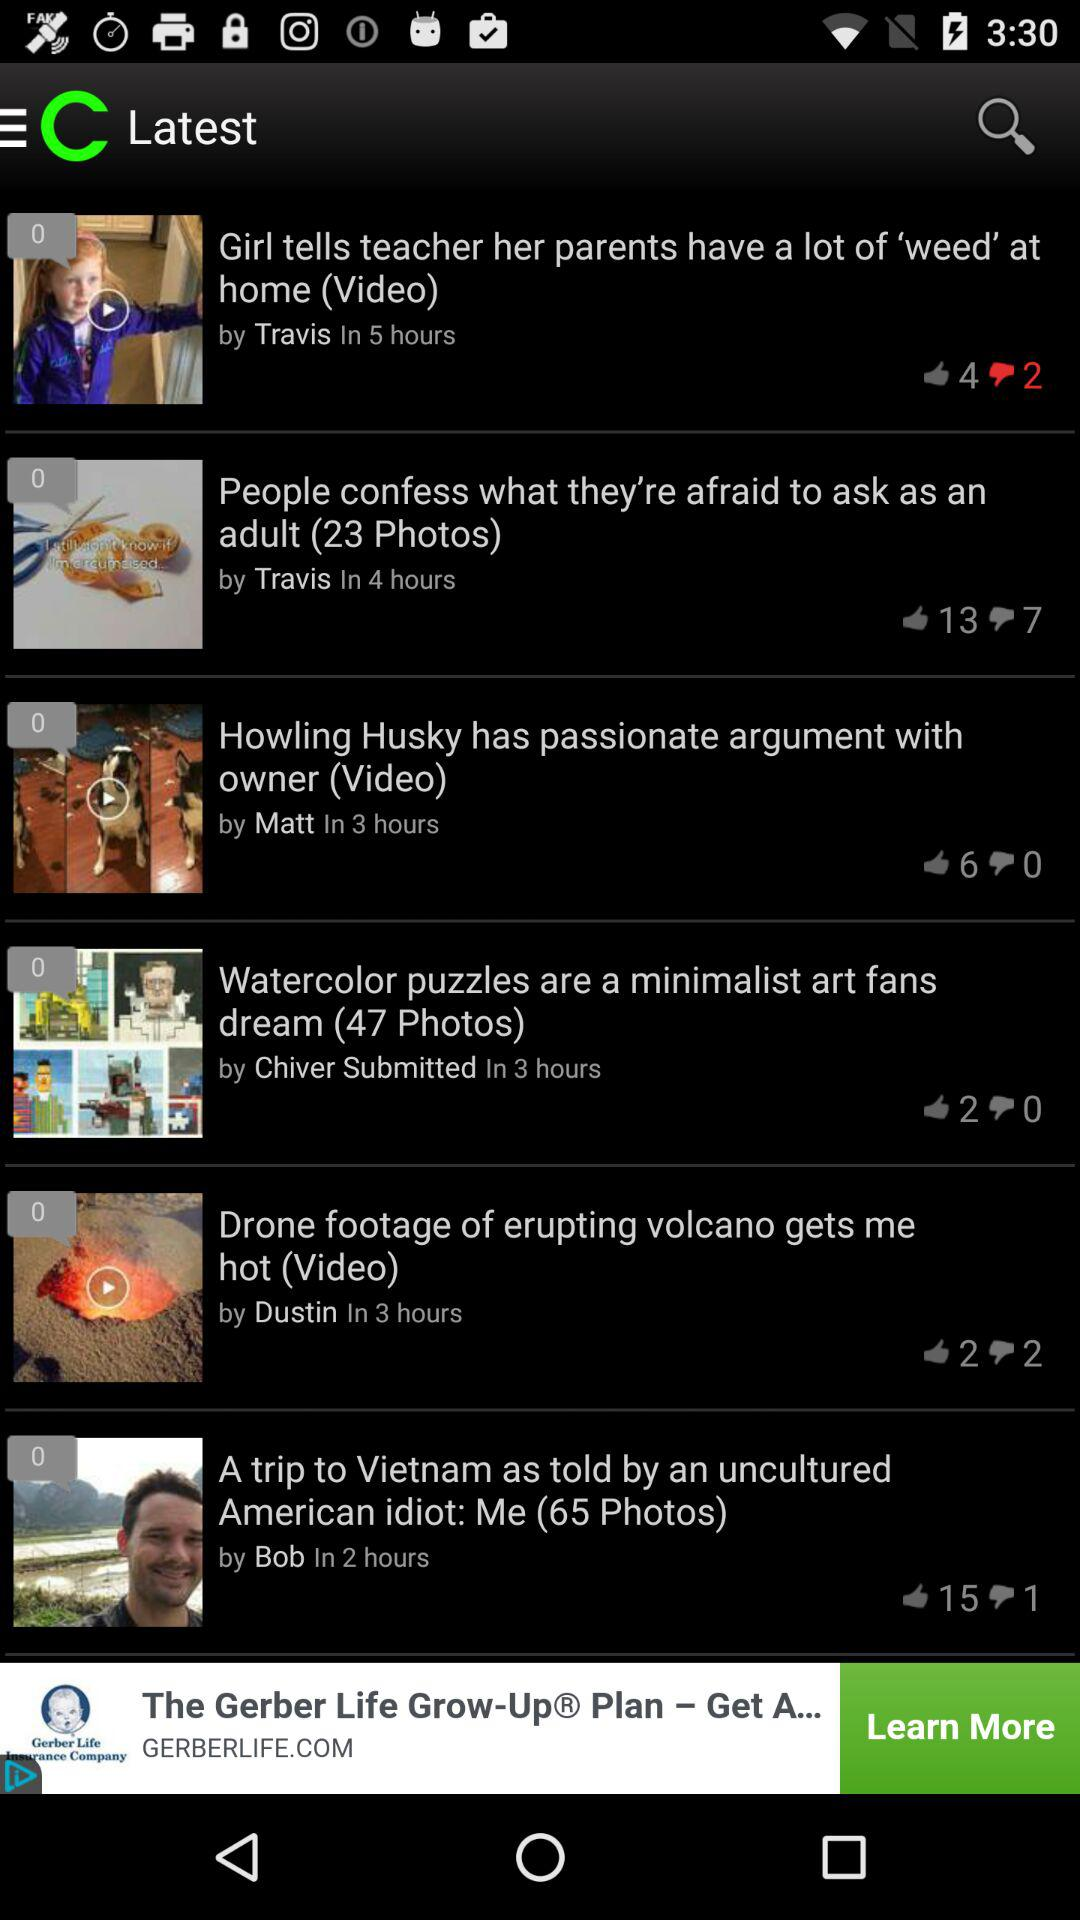On which day was the article by "Travis" posted?
When the provided information is insufficient, respond with <no answer>. <no answer> 